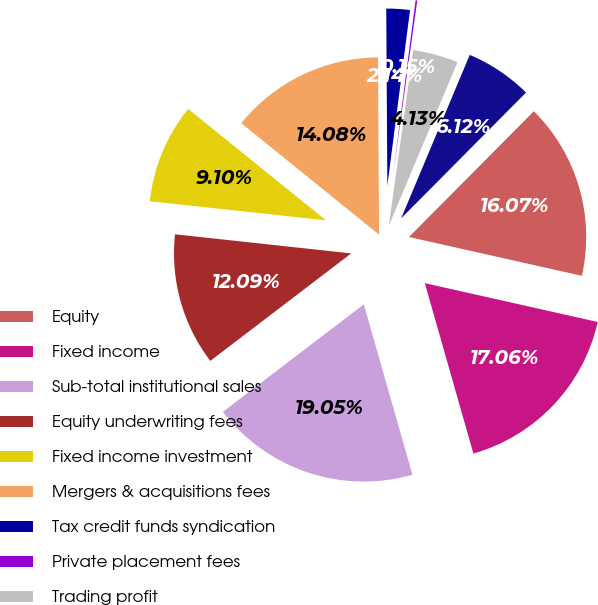Convert chart. <chart><loc_0><loc_0><loc_500><loc_500><pie_chart><fcel>Equity<fcel>Fixed income<fcel>Sub-total institutional sales<fcel>Equity underwriting fees<fcel>Fixed income investment<fcel>Mergers & acquisitions fees<fcel>Tax credit funds syndication<fcel>Private placement fees<fcel>Trading profit<fcel>Other<nl><fcel>16.07%<fcel>17.06%<fcel>19.05%<fcel>12.09%<fcel>9.1%<fcel>14.08%<fcel>2.14%<fcel>0.15%<fcel>4.13%<fcel>6.12%<nl></chart> 